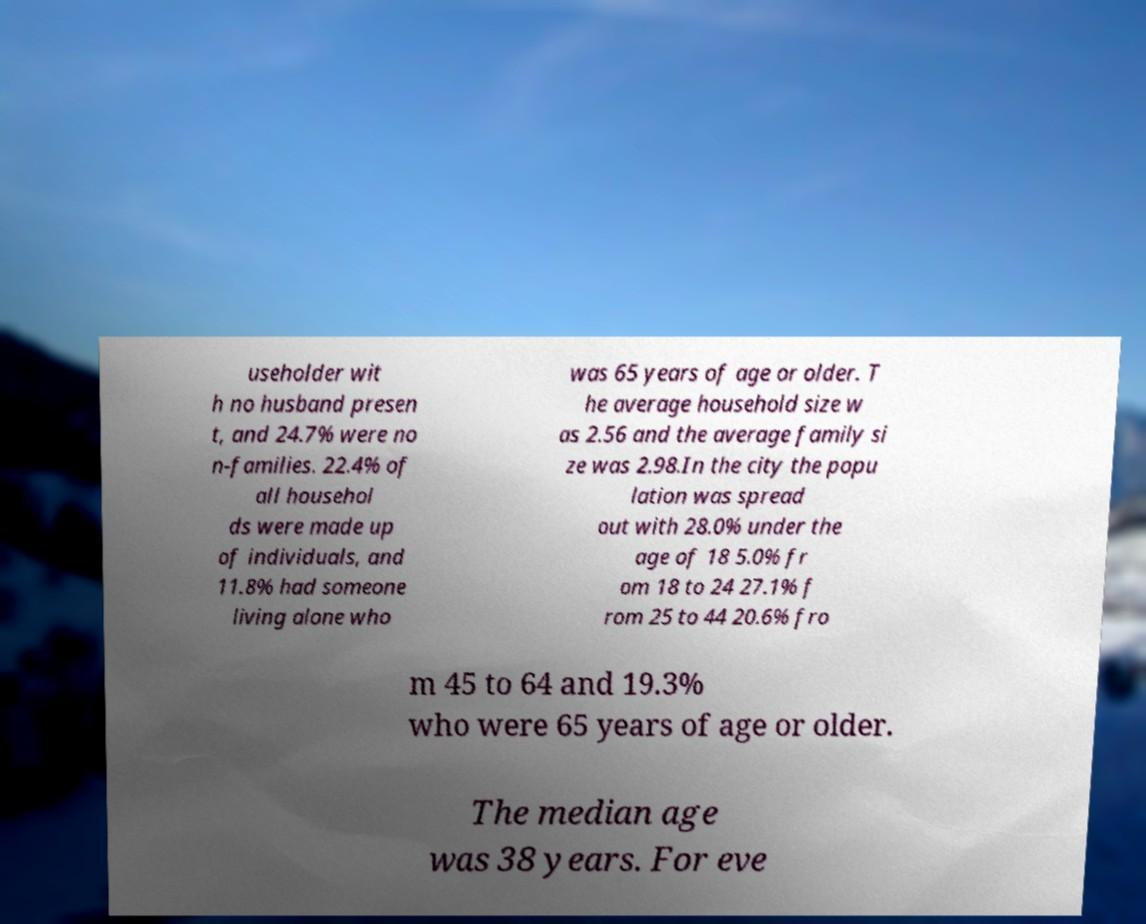I need the written content from this picture converted into text. Can you do that? useholder wit h no husband presen t, and 24.7% were no n-families. 22.4% of all househol ds were made up of individuals, and 11.8% had someone living alone who was 65 years of age or older. T he average household size w as 2.56 and the average family si ze was 2.98.In the city the popu lation was spread out with 28.0% under the age of 18 5.0% fr om 18 to 24 27.1% f rom 25 to 44 20.6% fro m 45 to 64 and 19.3% who were 65 years of age or older. The median age was 38 years. For eve 